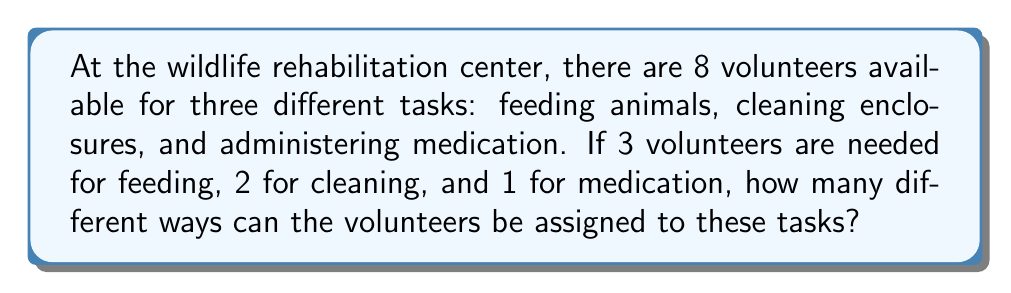What is the answer to this math problem? Let's approach this step-by-step using the multiplication principle of counting:

1) First, we need to choose 3 volunteers for feeding out of 8 available volunteers. This can be done in $\binom{8}{3}$ ways.

2) After assigning 3 volunteers to feeding, we have 5 volunteers left. From these 5, we need to choose 2 for cleaning. This can be done in $\binom{5}{2}$ ways.

3) After assigning volunteers to feeding and cleaning, we have 3 volunteers left, from which we need to choose 1 for medication. This can be done in $\binom{3}{1}$ ways.

4) By the multiplication principle, the total number of ways to assign volunteers is:

   $$\binom{8}{3} \cdot \binom{5}{2} \cdot \binom{3}{1}$$

5) Let's calculate each combination:
   
   $\binom{8}{3} = \frac{8!}{3!(8-3)!} = \frac{8!}{3!5!} = 56$
   
   $\binom{5}{2} = \frac{5!}{2!(5-2)!} = \frac{5!}{2!3!} = 10$
   
   $\binom{3}{1} = \frac{3!}{1!(3-1)!} = \frac{3!}{1!2!} = 3$

6) Multiplying these together:

   $56 \cdot 10 \cdot 3 = 1680$

Therefore, there are 1680 different ways to assign the volunteers to these tasks.
Answer: 1680 